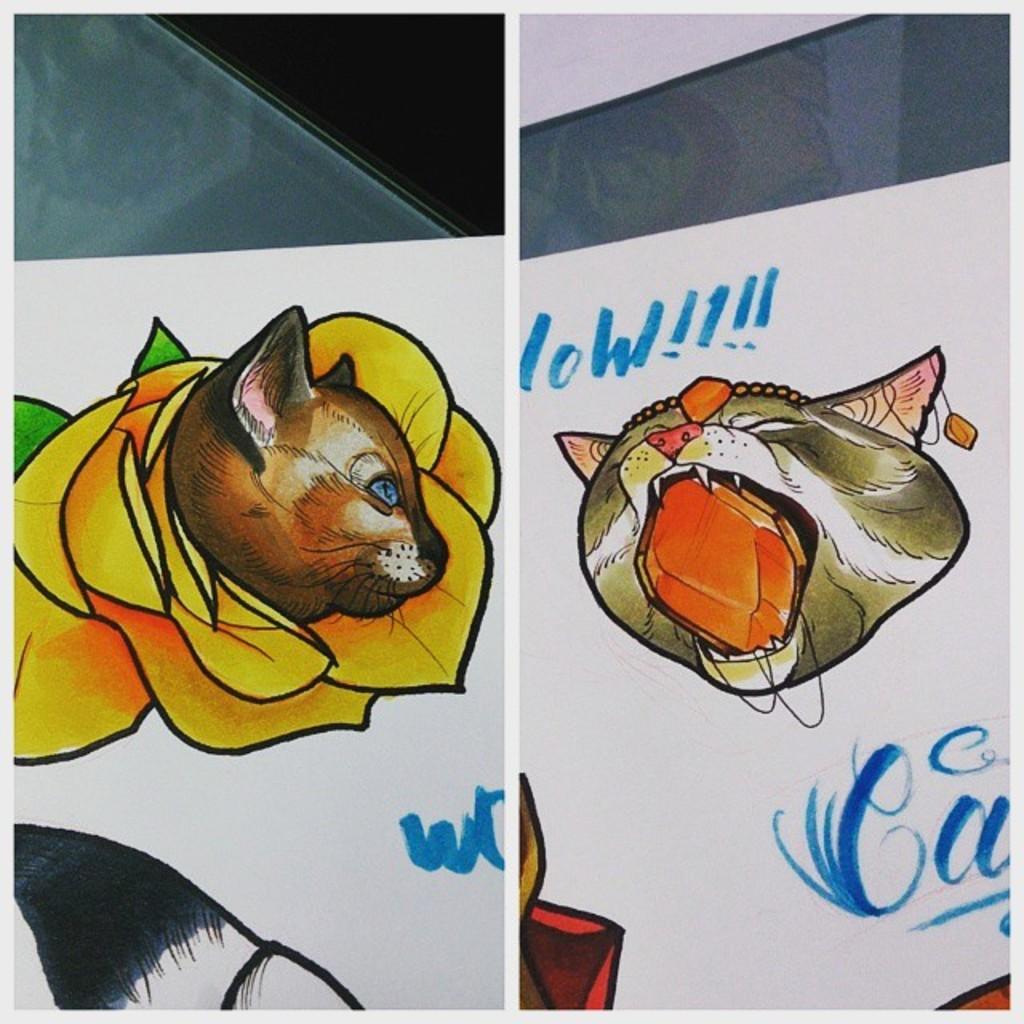Could you give a brief overview of what you see in this image? This picture contains the paintings of the flower and a cat. On the left side, we see the painting of the flower which is yellow in color. On the right side, we see the painting of a cat. We see some text written in blue color. In the background, it is white in color. 